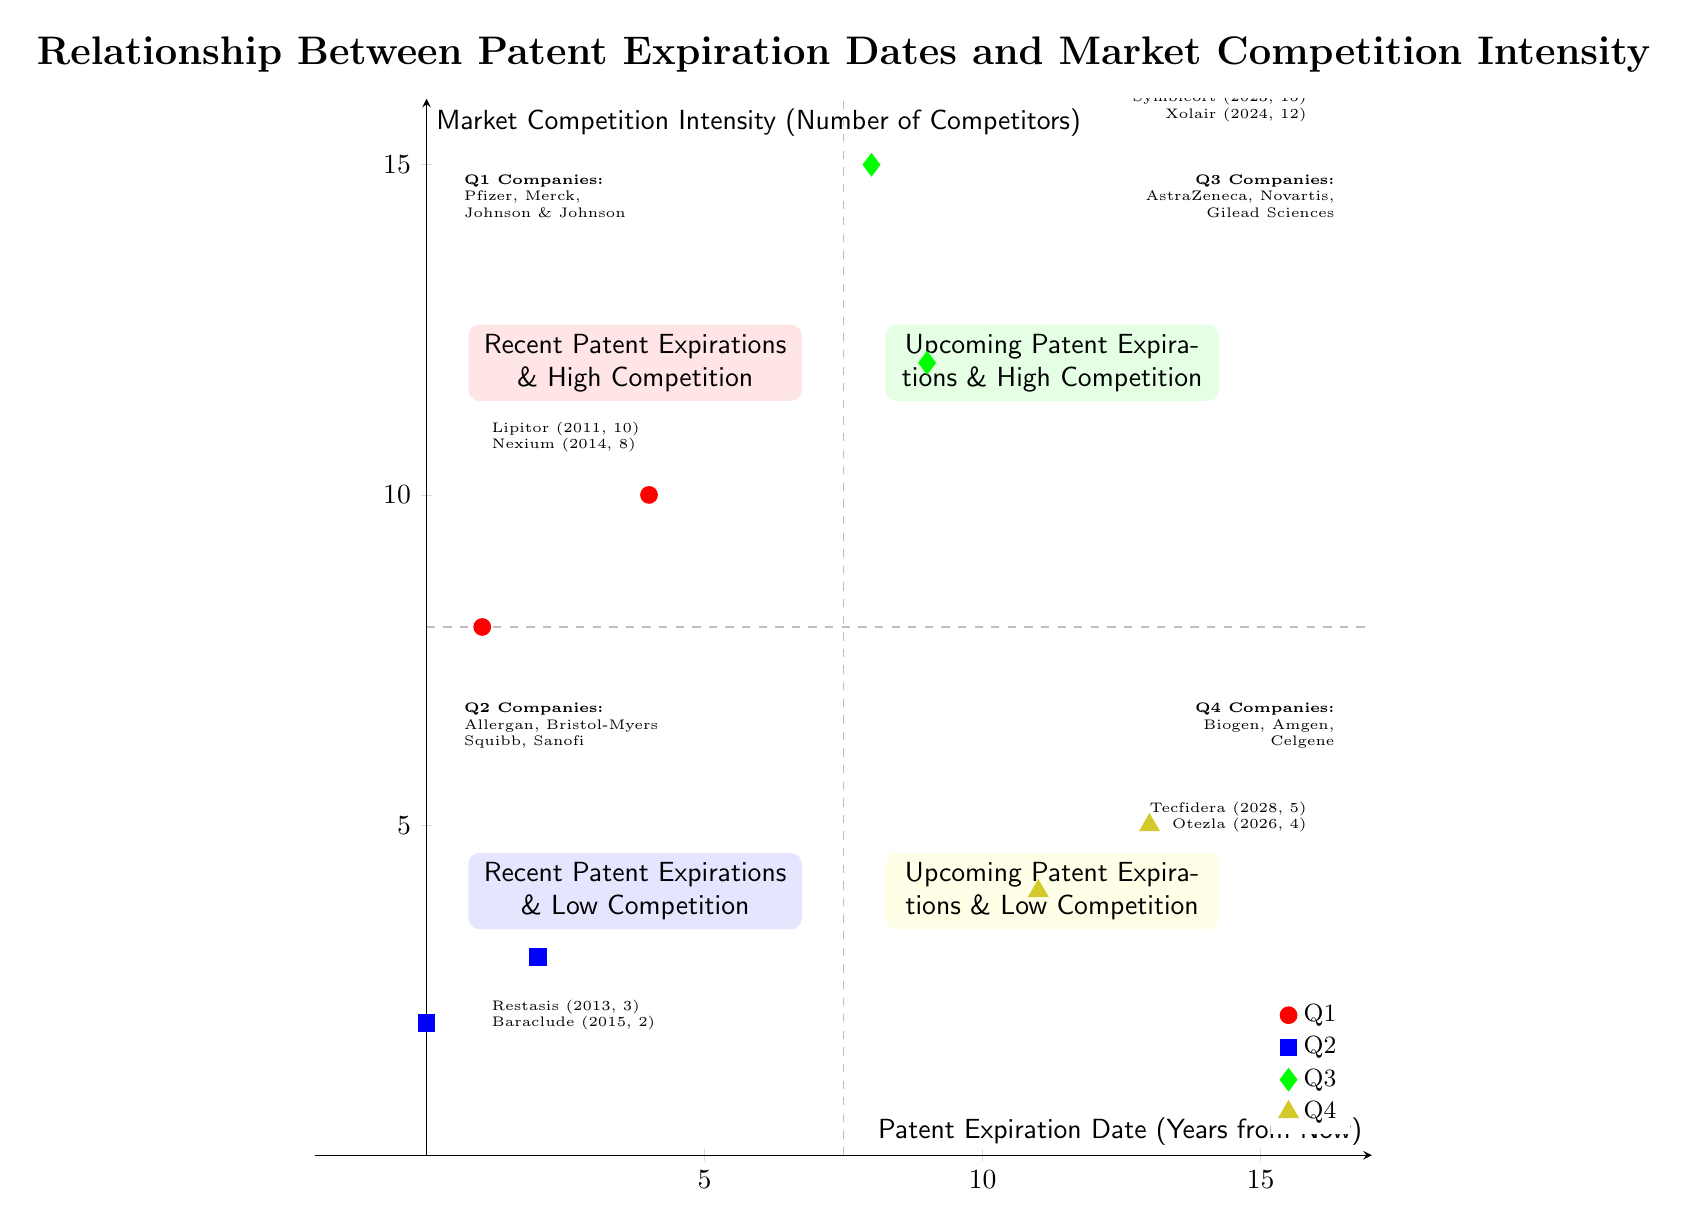What companies are in Q1? In Quadrant Q1, which represents Recent Patent Expirations & High Competition, the companies listed are Pfizer, Merck, and Johnson & Johnson.
Answer: Pfizer, Merck, Johnson & Johnson How many competitors does the drug Symbicort have? The drug Symbicort, which sits in Quadrant Q3 (Upcoming Patent Expirations & High Competition), has 15 competitors listed.
Answer: 15 What is the patent expiration year of the drug Otezla? The drug Otezla, located in Quadrant Q4 (Upcoming Patent Expirations & Low Competition), shows a patent expiration date of 2026.
Answer: 2026 What quadrant contains AstraZeneca? AstraZeneca appears in Quadrant Q3, which is labeled as Upcoming Patent Expirations & High Competition.
Answer: Q3 Which quadrant has the least number of competitors? Quadrant Q2, representing Recent Patent Expirations & Low Competition, has the least number of competitors, with a maximum of 3 competitors.
Answer: Q2 What is the relationship between patent expiration dates and market competition intensity in Q1? In Q1, drugs have recent patent expirations and high competition, indicating that the expiration of patents leads to increased market competition, as evidenced by the number of competitors for drugs like Lipitor and Nexium.
Answer: Recent expirations increase competition How many quadrants are there on the chart? The chart is divided into four quadrants, namely Q1, Q2, Q3, and Q4, each illustrating varying relationships between patent expiration dates and competition intensity in the pharma industry.
Answer: Four Which drug has the highest competition in Q3? The drug Symbicort has the highest competition in Q3, with 15 competitors noted next to it.
Answer: Symbicort What is the label for Q2? Quadrant Q2 is labeled as Recent Patent Expirations & Low Competition, which indicates drugs in this quadrant experience less market contention after patent expiry.
Answer: Recent Patent Expirations & Low Competition 